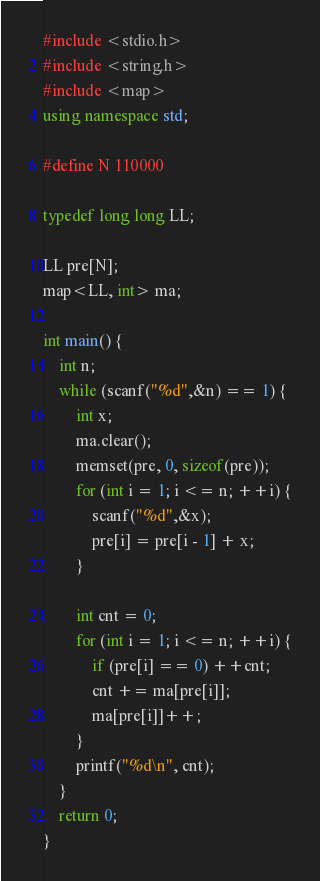Convert code to text. <code><loc_0><loc_0><loc_500><loc_500><_C++_>#include <stdio.h>
#include <string.h>
#include <map>
using namespace std;

#define N 110000

typedef long long LL;

LL pre[N];
map<LL, int> ma;

int main() {
    int n;
    while (scanf("%d",&n) == 1) {
        int x;
        ma.clear();
        memset(pre, 0, sizeof(pre));
        for (int i = 1; i <= n; ++i) {
            scanf("%d",&x);
            pre[i] = pre[i - 1] + x;
        }

        int cnt = 0;
        for (int i = 1; i <= n; ++i) {
            if (pre[i] == 0) ++cnt;
            cnt += ma[pre[i]];
            ma[pre[i]]++;
        }
        printf("%d\n", cnt);
    }
    return 0;
}
</code> 